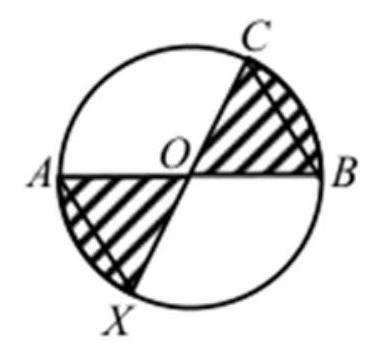How could a student correctly calculate the shaded area in this specific circle diagram? To calculate the shaded area, a student should start by identifying the areas of relevant circle sectors and any triangle areas within the sectors. Then, subtract the unshaded triangle areas from the sectors that partially cover them. This often involves using the formula for the area of a circle segment subtracted by the triangle area, applying the cosine rule in triangles, and understanding how the diameters divide the circle into parts. 